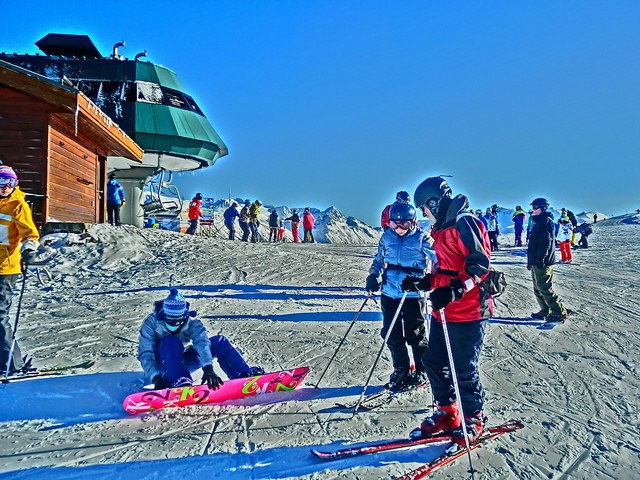Describe the objects in this image and their specific colors. I can see people in blue, black, navy, brown, and maroon tones, people in blue, black, and navy tones, people in blue, navy, and darkblue tones, snowboard in blue, brown, magenta, lightgray, and violet tones, and people in blue, navy, lightblue, and darkgray tones in this image. 